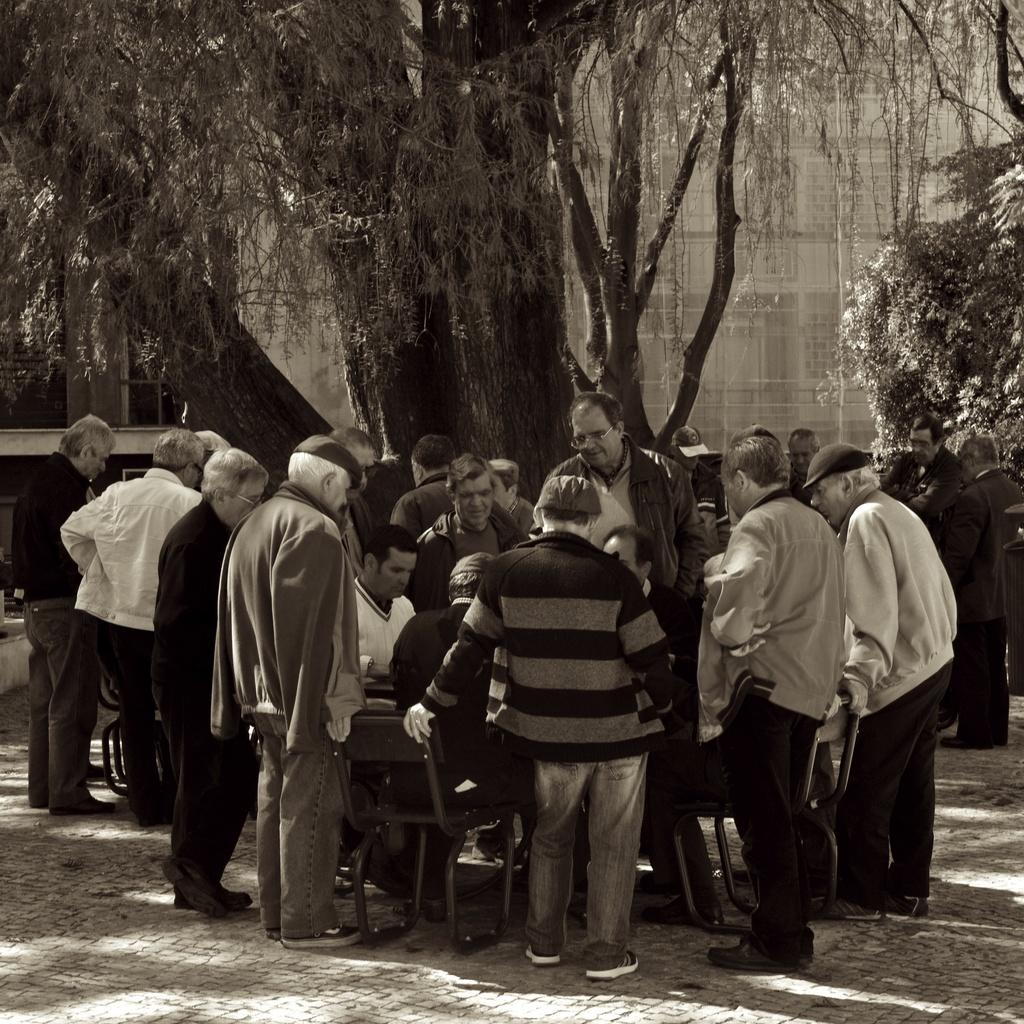How many people are in the image? There are multiple persons in the image. What are the people in the image doing? Some of the persons are standing, while others are sitting. What can be seen in the background of the image? There are trees and a building in the background of the image. What type of duck can be seen swimming in the image? There is no duck present in the image; it features multiple persons, trees, and a building in the background. 